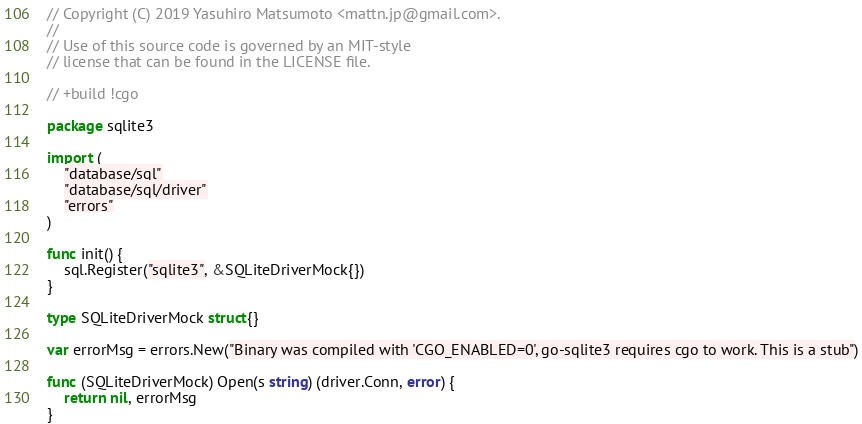<code> <loc_0><loc_0><loc_500><loc_500><_Go_>// Copyright (C) 2019 Yasuhiro Matsumoto <mattn.jp@gmail.com>.
//
// Use of this source code is governed by an MIT-style
// license that can be found in the LICENSE file.

// +build !cgo

package sqlite3

import (
	"database/sql"
	"database/sql/driver"
	"errors"
)

func init() {
	sql.Register("sqlite3", &SQLiteDriverMock{})
}

type SQLiteDriverMock struct{}

var errorMsg = errors.New("Binary was compiled with 'CGO_ENABLED=0', go-sqlite3 requires cgo to work. This is a stub")

func (SQLiteDriverMock) Open(s string) (driver.Conn, error) {
	return nil, errorMsg
}
</code> 